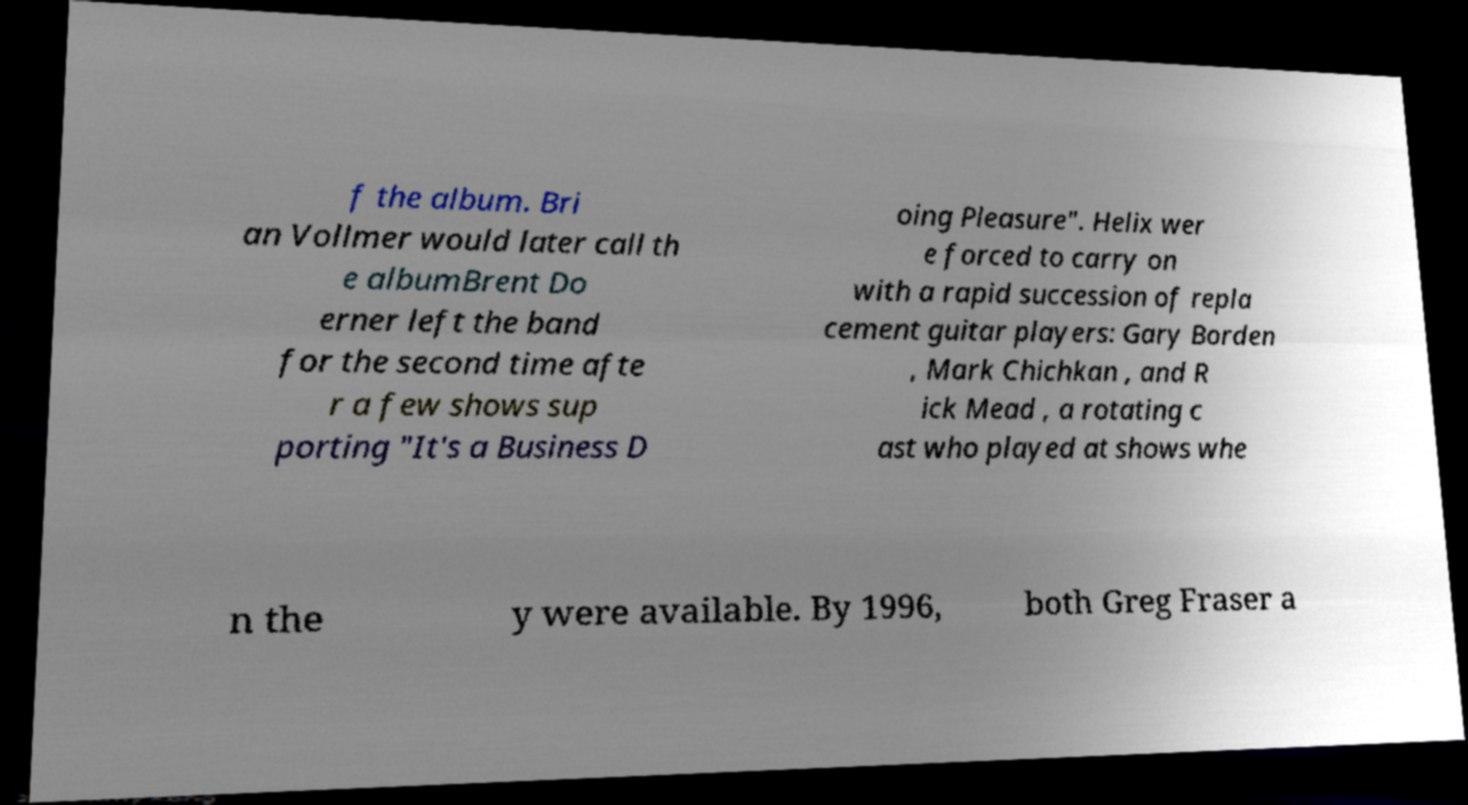For documentation purposes, I need the text within this image transcribed. Could you provide that? f the album. Bri an Vollmer would later call th e albumBrent Do erner left the band for the second time afte r a few shows sup porting "It's a Business D oing Pleasure". Helix wer e forced to carry on with a rapid succession of repla cement guitar players: Gary Borden , Mark Chichkan , and R ick Mead , a rotating c ast who played at shows whe n the y were available. By 1996, both Greg Fraser a 